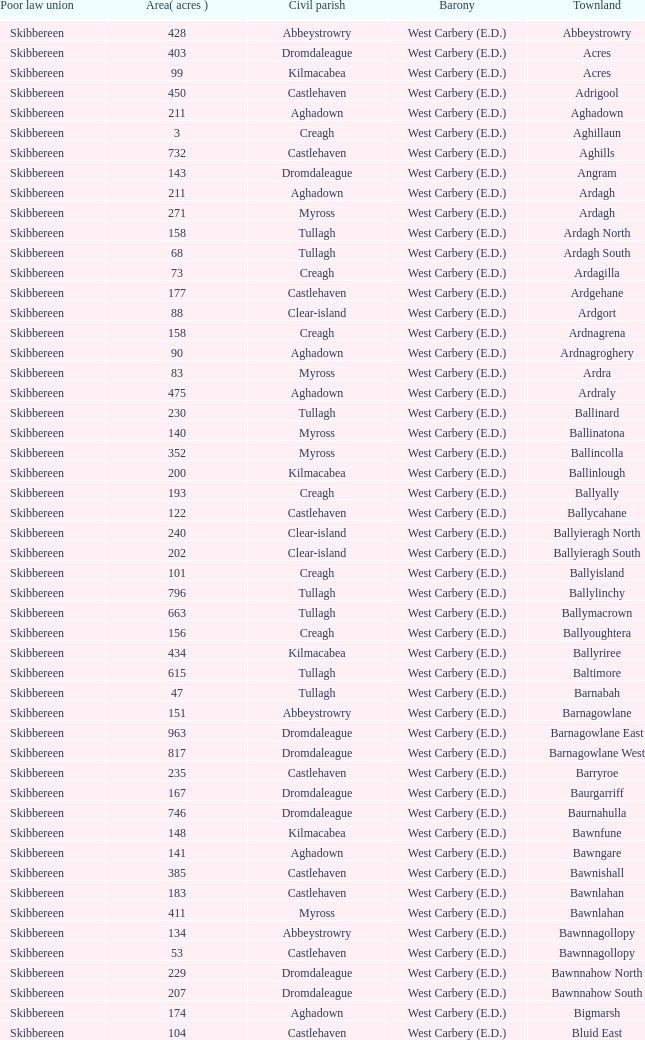What is the greatest area when the Poor Law Union is Skibbereen and the Civil Parish is Tullagh? 796.0. 